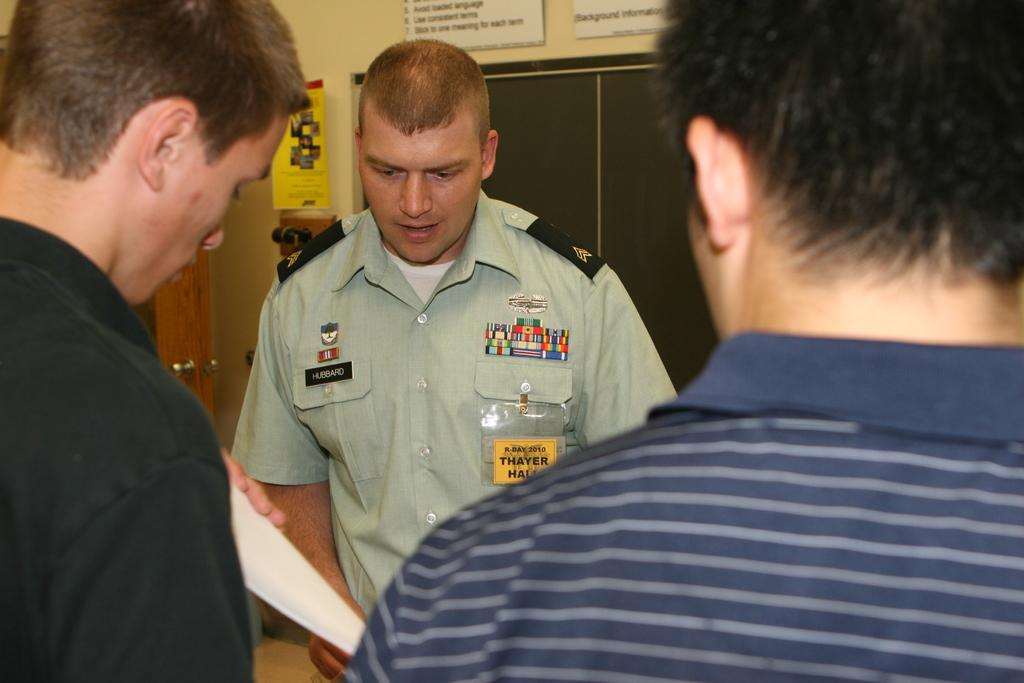<image>
Relay a brief, clear account of the picture shown. The officer wears a name badge saying Hubbard. 